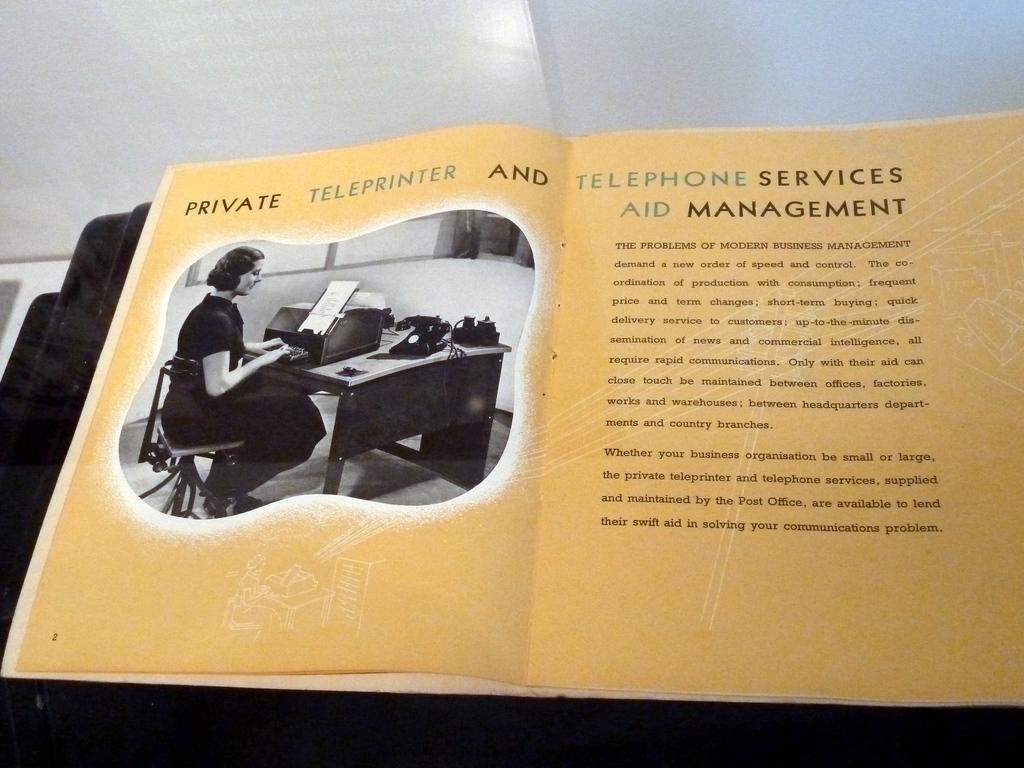What three words are in blue text?
Ensure brevity in your answer.  Teleprinter telephone aid. What is the last word of the header?
Offer a very short reply. Management. 